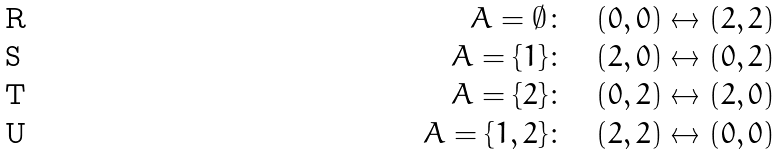Convert formula to latex. <formula><loc_0><loc_0><loc_500><loc_500>A = \emptyset \colon \quad ( 0 , 0 ) & \leftrightarrow ( 2 , 2 ) \\ A = \{ 1 \} \colon \quad ( 2 , 0 ) & \leftrightarrow ( 0 , 2 ) \\ A = \{ 2 \} \colon \quad ( 0 , 2 ) & \leftrightarrow ( 2 , 0 ) \\ A = \{ 1 , 2 \} \colon \quad ( 2 , 2 ) & \leftrightarrow ( 0 , 0 )</formula> 